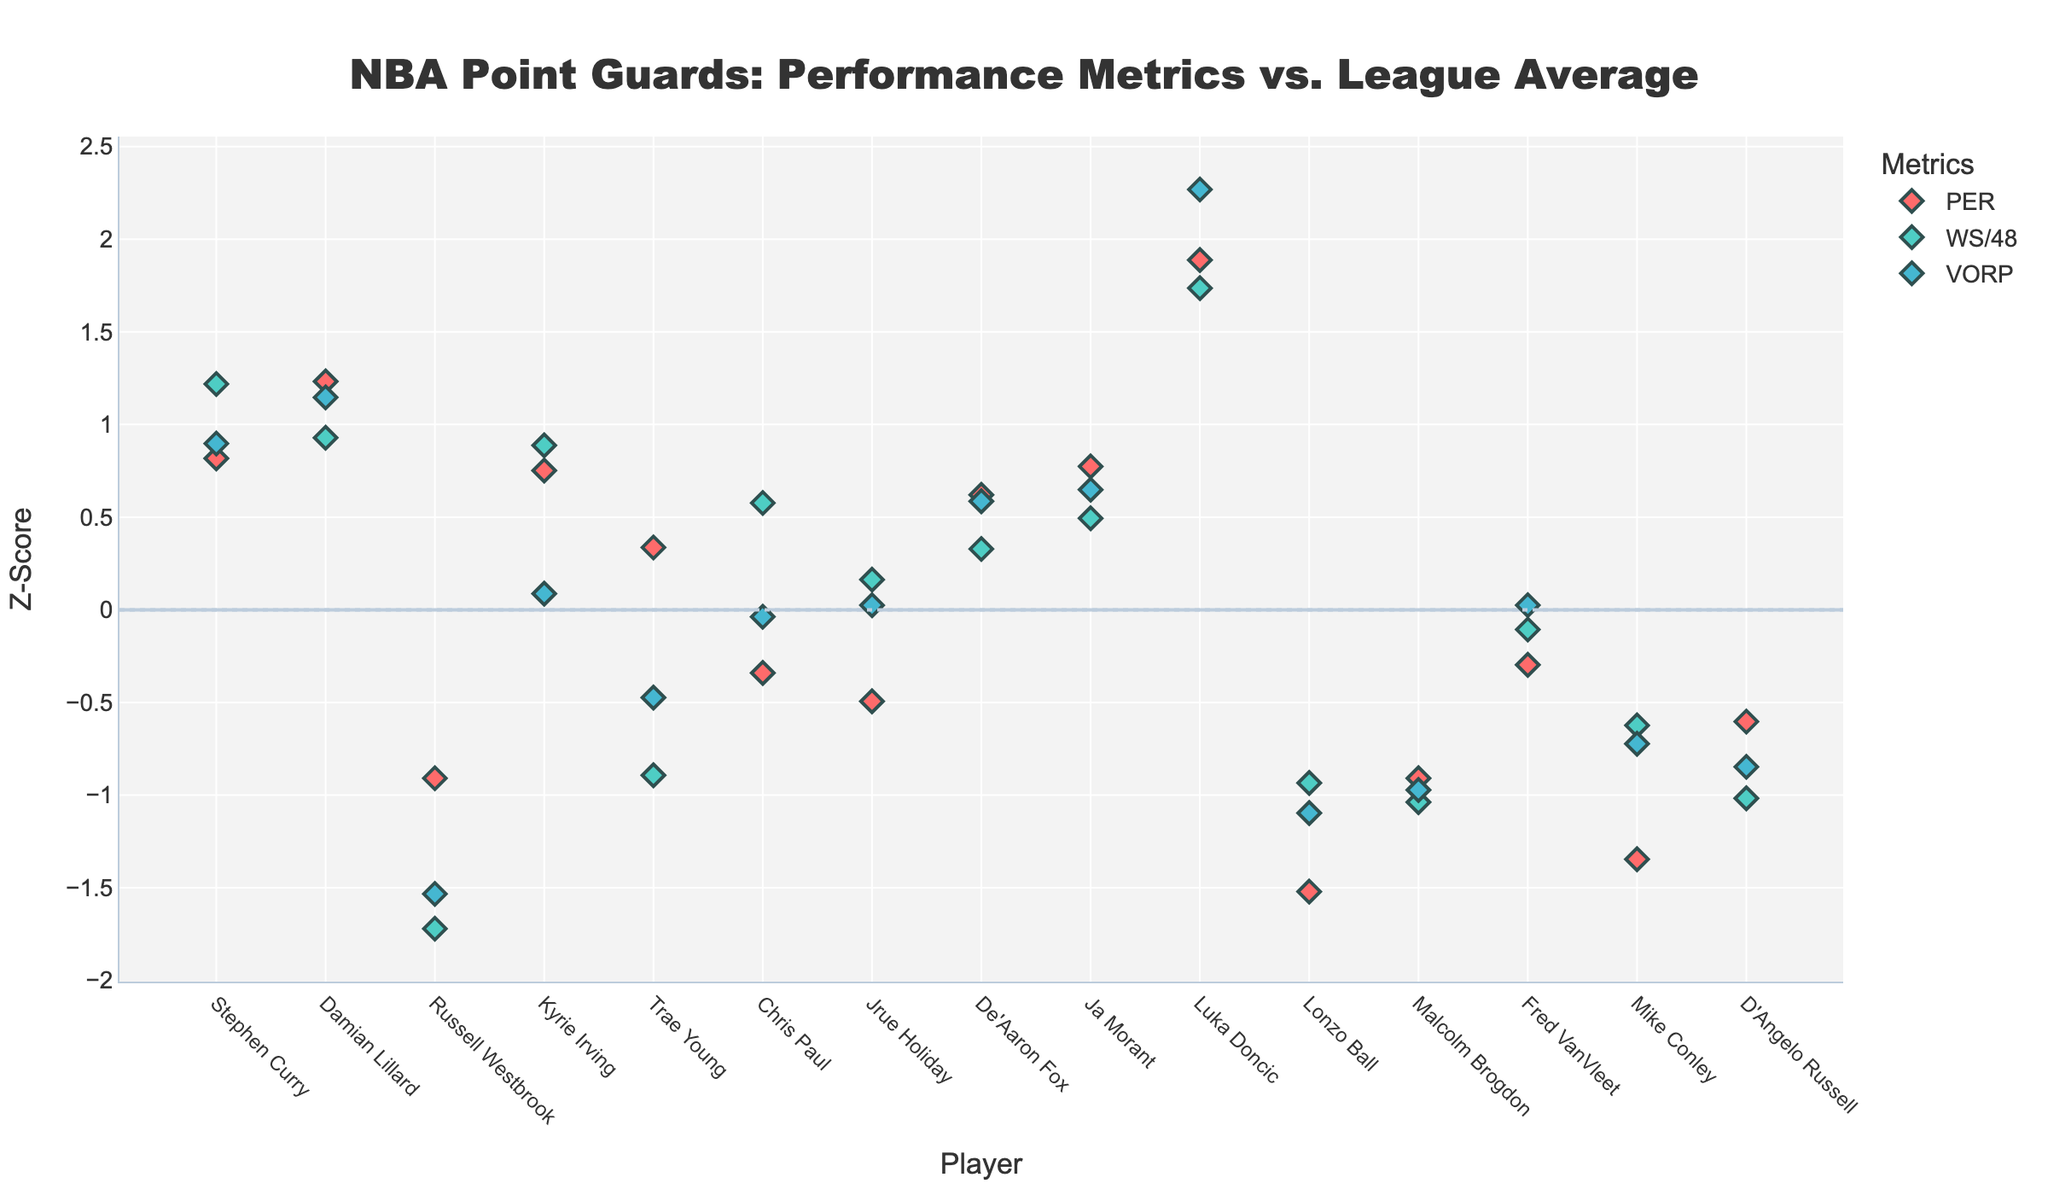Which player has the highest Z-score for VORP? By looking at the figure, locate the point with the highest vertical position in the VORP series (usually indicated by a certain color). The player's name under this point indicates who has the highest Z-score for VORP.
Answer: Luka Doncic Which metric shows the greatest variation among players? Variation can be assessed by the spread of Z-scores in the figure. The metric set with points most spread apart (widest range) from the zero line illustrates the greatest variation.
Answer: PER Which player is an outlier for having a low Z-score in PER but a high salary? Identify points in the PER series that are far below zero and cross-reference with the salaries indicated on hover. The player at the extreme low end of PER Z-scores with a high salary would be the outlier.
Answer: Russell Westbrook How many players have a Z-score above zero in all three metrics? Check each player's position in all three series (PER, WS/48, VORP). Count the number of players whose points in each metric are above the zero line.
Answer: 1 Compare the salaries of the top performers in PER and VORP. Are they similar? Identify the players with the highest Z-scores in PER and VORP. Compare their corresponding salaries as indicated by the hover text.
Answer: No, Stephen Curry and Luka Doncic have high salaries, but not similar Which player lies exactly on the zero line for WS/48? Find the point in the WS/48 series that is exactly on the zero line. The player's name under this point indicates who scores exactly average in WS/48.
Answer: No player What's the trend among players with Z-scores below zero in both PER and WS/48 regarding their salaries? Identify players who are below zero in both the PER and WS/48 series. Observe if their salaries tend to be lower or higher.
Answer: Generally, lower salaries Among the players listed, who has the most balanced high performance (non-zero positive Z-scores) across all three metrics? Locate players who have high (positive and similar) Z-scores in all three (PER, WS/48, VORP) metrics. Cross-reference the names and observe their Z-scores.
Answer: Luka Doncic Who among the players has the closest performance to the league average in all metrics? Find the player whose points are nearest the zero line for all three series (PER, WS/48, VORP). This indicates performance closest to the league average.
Answer: Fred VanVleet 